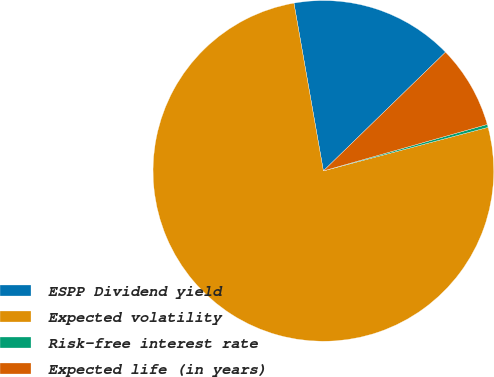Convert chart to OTSL. <chart><loc_0><loc_0><loc_500><loc_500><pie_chart><fcel>ESPP Dividend yield<fcel>Expected volatility<fcel>Risk-free interest rate<fcel>Expected life (in years)<nl><fcel>15.49%<fcel>76.35%<fcel>0.28%<fcel>7.88%<nl></chart> 